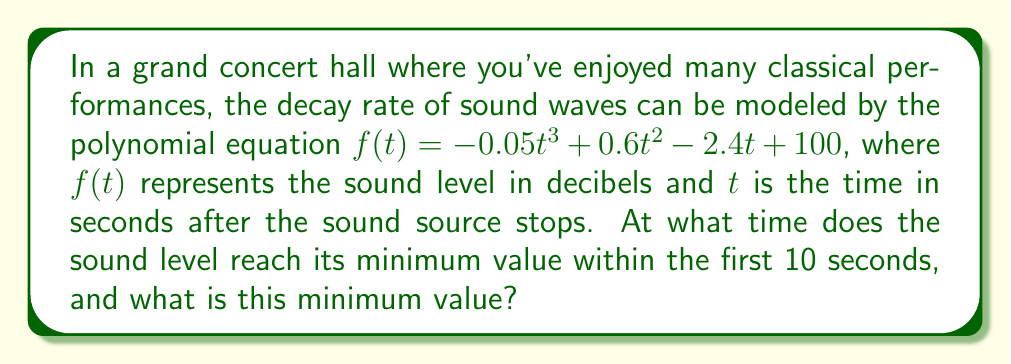Can you solve this math problem? To find the minimum value of the function within the first 10 seconds, we need to follow these steps:

1) First, we need to find the derivative of the function:
   $$f'(t) = -0.15t^2 + 1.2t - 2.4$$

2) Set the derivative equal to zero and solve for t:
   $$-0.15t^2 + 1.2t - 2.4 = 0$$
   
   This is a quadratic equation. We can solve it using the quadratic formula:
   $$t = \frac{-b \pm \sqrt{b^2 - 4ac}}{2a}$$
   
   Where $a = -0.15$, $b = 1.2$, and $c = -2.4$

3) Plugging in these values:
   $$t = \frac{-1.2 \pm \sqrt{1.44 - 4(-0.15)(-2.4)}}{2(-0.15)}$$
   $$= \frac{-1.2 \pm \sqrt{1.44 - 1.44}}{-0.3}$$
   $$= \frac{-1.2 \pm 0}{-0.3} = 4$$

4) We find that the critical point occurs at $t = 4$ seconds. To confirm this is a minimum (not a maximum), we can check the second derivative:
   $$f''(t) = -0.3t + 1.2$$
   $$f''(4) = -0.3(4) + 1.2 = 0$$
   
   Since $f''(4) > 0$, this confirms that $t = 4$ is indeed a minimum.

5) To find the minimum value, we plug $t = 4$ into our original function:
   $$f(4) = -0.05(4)^3 + 0.6(4)^2 - 2.4(4) + 100$$
   $$= -3.2 + 9.6 - 9.6 + 100 = 96.8$$

Therefore, the sound level reaches its minimum value of 96.8 decibels at 4 seconds after the sound source stops.
Answer: The sound level reaches its minimum value of 96.8 decibels at t = 4 seconds. 